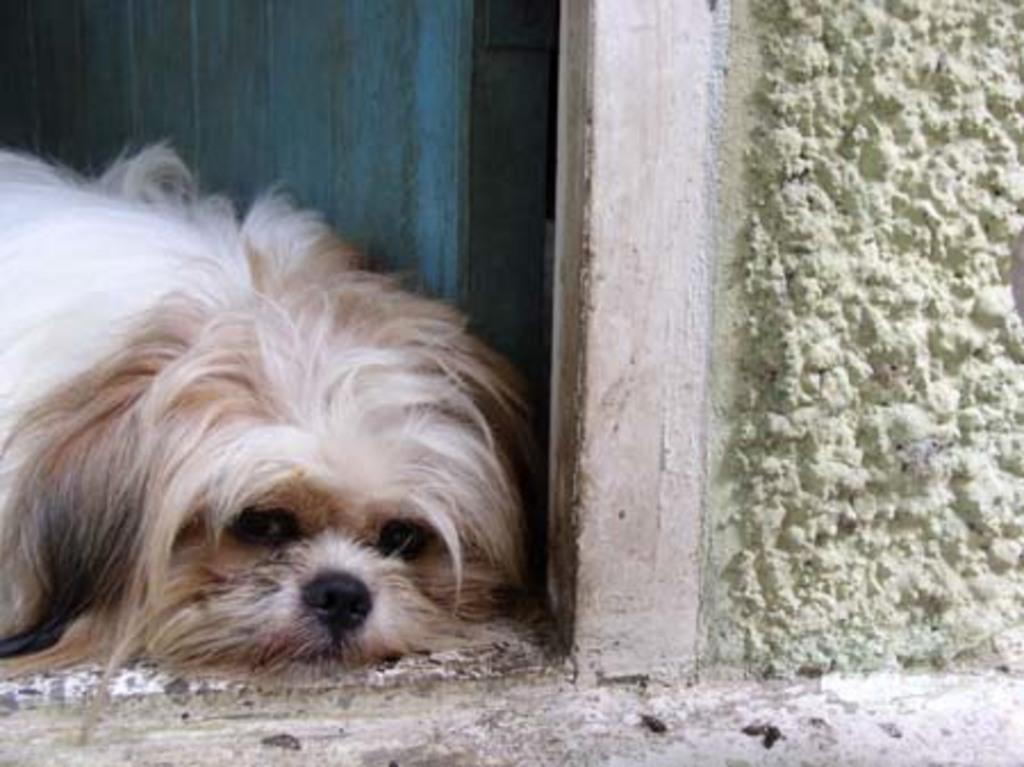What type of animal can be seen in the picture? There is a dog in the picture. What is located in the background of the picture? There is a wooden door in the background of the picture. What is on the right side of the picture? There is a wall on the right side of the picture. Can you see any fairies playing near the lake in the image? There is no lake or fairies present in the image; it features a dog and a wooden door in the background. 